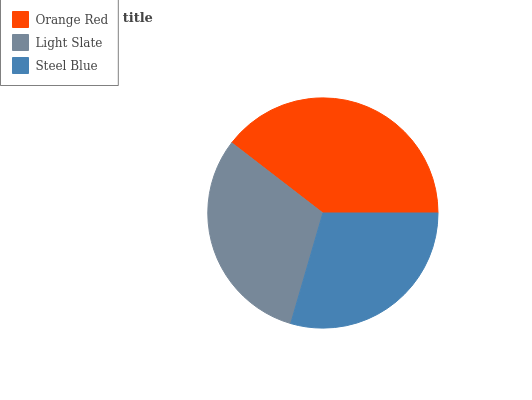Is Steel Blue the minimum?
Answer yes or no. Yes. Is Orange Red the maximum?
Answer yes or no. Yes. Is Light Slate the minimum?
Answer yes or no. No. Is Light Slate the maximum?
Answer yes or no. No. Is Orange Red greater than Light Slate?
Answer yes or no. Yes. Is Light Slate less than Orange Red?
Answer yes or no. Yes. Is Light Slate greater than Orange Red?
Answer yes or no. No. Is Orange Red less than Light Slate?
Answer yes or no. No. Is Light Slate the high median?
Answer yes or no. Yes. Is Light Slate the low median?
Answer yes or no. Yes. Is Steel Blue the high median?
Answer yes or no. No. Is Steel Blue the low median?
Answer yes or no. No. 